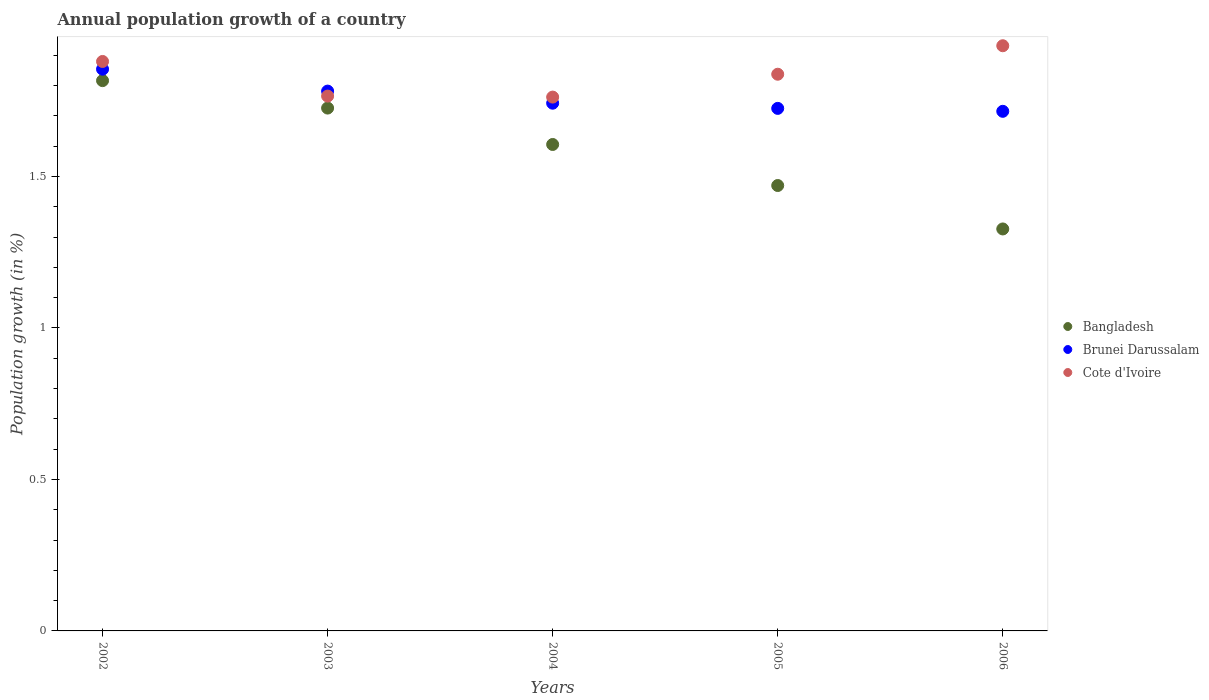What is the annual population growth in Cote d'Ivoire in 2002?
Give a very brief answer. 1.88. Across all years, what is the maximum annual population growth in Bangladesh?
Offer a very short reply. 1.82. Across all years, what is the minimum annual population growth in Cote d'Ivoire?
Ensure brevity in your answer.  1.76. In which year was the annual population growth in Cote d'Ivoire minimum?
Make the answer very short. 2004. What is the total annual population growth in Bangladesh in the graph?
Make the answer very short. 7.95. What is the difference between the annual population growth in Brunei Darussalam in 2005 and that in 2006?
Your answer should be compact. 0.01. What is the difference between the annual population growth in Brunei Darussalam in 2006 and the annual population growth in Bangladesh in 2004?
Give a very brief answer. 0.11. What is the average annual population growth in Bangladesh per year?
Your answer should be compact. 1.59. In the year 2002, what is the difference between the annual population growth in Cote d'Ivoire and annual population growth in Bangladesh?
Ensure brevity in your answer.  0.06. In how many years, is the annual population growth in Bangladesh greater than 1.8 %?
Keep it short and to the point. 1. What is the ratio of the annual population growth in Brunei Darussalam in 2002 to that in 2004?
Your answer should be compact. 1.06. Is the difference between the annual population growth in Cote d'Ivoire in 2004 and 2006 greater than the difference between the annual population growth in Bangladesh in 2004 and 2006?
Provide a short and direct response. No. What is the difference between the highest and the second highest annual population growth in Bangladesh?
Give a very brief answer. 0.09. What is the difference between the highest and the lowest annual population growth in Cote d'Ivoire?
Ensure brevity in your answer.  0.17. In how many years, is the annual population growth in Cote d'Ivoire greater than the average annual population growth in Cote d'Ivoire taken over all years?
Your response must be concise. 3. Is the annual population growth in Brunei Darussalam strictly less than the annual population growth in Bangladesh over the years?
Offer a very short reply. No. How many dotlines are there?
Your response must be concise. 3. How many years are there in the graph?
Provide a short and direct response. 5. What is the difference between two consecutive major ticks on the Y-axis?
Give a very brief answer. 0.5. Does the graph contain any zero values?
Offer a terse response. No. What is the title of the graph?
Your response must be concise. Annual population growth of a country. Does "Turkey" appear as one of the legend labels in the graph?
Offer a terse response. No. What is the label or title of the X-axis?
Give a very brief answer. Years. What is the label or title of the Y-axis?
Offer a terse response. Population growth (in %). What is the Population growth (in %) in Bangladesh in 2002?
Offer a terse response. 1.82. What is the Population growth (in %) of Brunei Darussalam in 2002?
Offer a terse response. 1.85. What is the Population growth (in %) in Cote d'Ivoire in 2002?
Give a very brief answer. 1.88. What is the Population growth (in %) in Bangladesh in 2003?
Your response must be concise. 1.73. What is the Population growth (in %) of Brunei Darussalam in 2003?
Ensure brevity in your answer.  1.78. What is the Population growth (in %) of Cote d'Ivoire in 2003?
Offer a very short reply. 1.77. What is the Population growth (in %) in Bangladesh in 2004?
Your answer should be very brief. 1.61. What is the Population growth (in %) of Brunei Darussalam in 2004?
Your answer should be compact. 1.74. What is the Population growth (in %) in Cote d'Ivoire in 2004?
Provide a short and direct response. 1.76. What is the Population growth (in %) in Bangladesh in 2005?
Offer a terse response. 1.47. What is the Population growth (in %) in Brunei Darussalam in 2005?
Ensure brevity in your answer.  1.72. What is the Population growth (in %) in Cote d'Ivoire in 2005?
Ensure brevity in your answer.  1.84. What is the Population growth (in %) of Bangladesh in 2006?
Offer a very short reply. 1.33. What is the Population growth (in %) of Brunei Darussalam in 2006?
Keep it short and to the point. 1.72. What is the Population growth (in %) in Cote d'Ivoire in 2006?
Offer a terse response. 1.93. Across all years, what is the maximum Population growth (in %) of Bangladesh?
Provide a succinct answer. 1.82. Across all years, what is the maximum Population growth (in %) of Brunei Darussalam?
Ensure brevity in your answer.  1.85. Across all years, what is the maximum Population growth (in %) in Cote d'Ivoire?
Your answer should be very brief. 1.93. Across all years, what is the minimum Population growth (in %) of Bangladesh?
Offer a terse response. 1.33. Across all years, what is the minimum Population growth (in %) in Brunei Darussalam?
Ensure brevity in your answer.  1.72. Across all years, what is the minimum Population growth (in %) in Cote d'Ivoire?
Make the answer very short. 1.76. What is the total Population growth (in %) of Bangladesh in the graph?
Give a very brief answer. 7.95. What is the total Population growth (in %) in Brunei Darussalam in the graph?
Keep it short and to the point. 8.82. What is the total Population growth (in %) of Cote d'Ivoire in the graph?
Provide a succinct answer. 9.18. What is the difference between the Population growth (in %) in Bangladesh in 2002 and that in 2003?
Offer a terse response. 0.09. What is the difference between the Population growth (in %) of Brunei Darussalam in 2002 and that in 2003?
Offer a terse response. 0.07. What is the difference between the Population growth (in %) in Cote d'Ivoire in 2002 and that in 2003?
Provide a succinct answer. 0.11. What is the difference between the Population growth (in %) of Bangladesh in 2002 and that in 2004?
Your response must be concise. 0.21. What is the difference between the Population growth (in %) in Brunei Darussalam in 2002 and that in 2004?
Provide a short and direct response. 0.11. What is the difference between the Population growth (in %) of Cote d'Ivoire in 2002 and that in 2004?
Offer a very short reply. 0.12. What is the difference between the Population growth (in %) of Bangladesh in 2002 and that in 2005?
Ensure brevity in your answer.  0.35. What is the difference between the Population growth (in %) of Brunei Darussalam in 2002 and that in 2005?
Your response must be concise. 0.13. What is the difference between the Population growth (in %) of Cote d'Ivoire in 2002 and that in 2005?
Offer a terse response. 0.04. What is the difference between the Population growth (in %) of Bangladesh in 2002 and that in 2006?
Offer a terse response. 0.49. What is the difference between the Population growth (in %) of Brunei Darussalam in 2002 and that in 2006?
Your answer should be compact. 0.14. What is the difference between the Population growth (in %) of Cote d'Ivoire in 2002 and that in 2006?
Your answer should be very brief. -0.05. What is the difference between the Population growth (in %) in Bangladesh in 2003 and that in 2004?
Offer a very short reply. 0.12. What is the difference between the Population growth (in %) in Brunei Darussalam in 2003 and that in 2004?
Offer a terse response. 0.04. What is the difference between the Population growth (in %) of Cote d'Ivoire in 2003 and that in 2004?
Provide a succinct answer. 0. What is the difference between the Population growth (in %) of Bangladesh in 2003 and that in 2005?
Your answer should be very brief. 0.26. What is the difference between the Population growth (in %) in Brunei Darussalam in 2003 and that in 2005?
Your answer should be compact. 0.06. What is the difference between the Population growth (in %) of Cote d'Ivoire in 2003 and that in 2005?
Your answer should be very brief. -0.07. What is the difference between the Population growth (in %) in Bangladesh in 2003 and that in 2006?
Keep it short and to the point. 0.4. What is the difference between the Population growth (in %) of Brunei Darussalam in 2003 and that in 2006?
Offer a very short reply. 0.07. What is the difference between the Population growth (in %) of Cote d'Ivoire in 2003 and that in 2006?
Your answer should be compact. -0.17. What is the difference between the Population growth (in %) in Bangladesh in 2004 and that in 2005?
Provide a succinct answer. 0.14. What is the difference between the Population growth (in %) in Brunei Darussalam in 2004 and that in 2005?
Offer a very short reply. 0.02. What is the difference between the Population growth (in %) of Cote d'Ivoire in 2004 and that in 2005?
Your response must be concise. -0.08. What is the difference between the Population growth (in %) of Bangladesh in 2004 and that in 2006?
Provide a succinct answer. 0.28. What is the difference between the Population growth (in %) of Brunei Darussalam in 2004 and that in 2006?
Your response must be concise. 0.03. What is the difference between the Population growth (in %) in Cote d'Ivoire in 2004 and that in 2006?
Make the answer very short. -0.17. What is the difference between the Population growth (in %) in Bangladesh in 2005 and that in 2006?
Offer a very short reply. 0.14. What is the difference between the Population growth (in %) of Brunei Darussalam in 2005 and that in 2006?
Your response must be concise. 0.01. What is the difference between the Population growth (in %) in Cote d'Ivoire in 2005 and that in 2006?
Make the answer very short. -0.09. What is the difference between the Population growth (in %) of Bangladesh in 2002 and the Population growth (in %) of Brunei Darussalam in 2003?
Keep it short and to the point. 0.03. What is the difference between the Population growth (in %) in Bangladesh in 2002 and the Population growth (in %) in Cote d'Ivoire in 2003?
Make the answer very short. 0.05. What is the difference between the Population growth (in %) in Brunei Darussalam in 2002 and the Population growth (in %) in Cote d'Ivoire in 2003?
Your answer should be very brief. 0.09. What is the difference between the Population growth (in %) of Bangladesh in 2002 and the Population growth (in %) of Brunei Darussalam in 2004?
Make the answer very short. 0.07. What is the difference between the Population growth (in %) in Bangladesh in 2002 and the Population growth (in %) in Cote d'Ivoire in 2004?
Offer a very short reply. 0.05. What is the difference between the Population growth (in %) in Brunei Darussalam in 2002 and the Population growth (in %) in Cote d'Ivoire in 2004?
Ensure brevity in your answer.  0.09. What is the difference between the Population growth (in %) in Bangladesh in 2002 and the Population growth (in %) in Brunei Darussalam in 2005?
Offer a very short reply. 0.09. What is the difference between the Population growth (in %) of Bangladesh in 2002 and the Population growth (in %) of Cote d'Ivoire in 2005?
Give a very brief answer. -0.02. What is the difference between the Population growth (in %) of Brunei Darussalam in 2002 and the Population growth (in %) of Cote d'Ivoire in 2005?
Provide a succinct answer. 0.02. What is the difference between the Population growth (in %) of Bangladesh in 2002 and the Population growth (in %) of Brunei Darussalam in 2006?
Your answer should be very brief. 0.1. What is the difference between the Population growth (in %) of Bangladesh in 2002 and the Population growth (in %) of Cote d'Ivoire in 2006?
Your answer should be compact. -0.12. What is the difference between the Population growth (in %) of Brunei Darussalam in 2002 and the Population growth (in %) of Cote d'Ivoire in 2006?
Keep it short and to the point. -0.08. What is the difference between the Population growth (in %) in Bangladesh in 2003 and the Population growth (in %) in Brunei Darussalam in 2004?
Make the answer very short. -0.02. What is the difference between the Population growth (in %) in Bangladesh in 2003 and the Population growth (in %) in Cote d'Ivoire in 2004?
Provide a short and direct response. -0.04. What is the difference between the Population growth (in %) of Brunei Darussalam in 2003 and the Population growth (in %) of Cote d'Ivoire in 2004?
Provide a succinct answer. 0.02. What is the difference between the Population growth (in %) of Bangladesh in 2003 and the Population growth (in %) of Brunei Darussalam in 2005?
Give a very brief answer. 0. What is the difference between the Population growth (in %) in Bangladesh in 2003 and the Population growth (in %) in Cote d'Ivoire in 2005?
Provide a short and direct response. -0.11. What is the difference between the Population growth (in %) in Brunei Darussalam in 2003 and the Population growth (in %) in Cote d'Ivoire in 2005?
Your response must be concise. -0.06. What is the difference between the Population growth (in %) of Bangladesh in 2003 and the Population growth (in %) of Brunei Darussalam in 2006?
Make the answer very short. 0.01. What is the difference between the Population growth (in %) of Bangladesh in 2003 and the Population growth (in %) of Cote d'Ivoire in 2006?
Provide a succinct answer. -0.21. What is the difference between the Population growth (in %) in Brunei Darussalam in 2003 and the Population growth (in %) in Cote d'Ivoire in 2006?
Provide a short and direct response. -0.15. What is the difference between the Population growth (in %) in Bangladesh in 2004 and the Population growth (in %) in Brunei Darussalam in 2005?
Your response must be concise. -0.12. What is the difference between the Population growth (in %) in Bangladesh in 2004 and the Population growth (in %) in Cote d'Ivoire in 2005?
Make the answer very short. -0.23. What is the difference between the Population growth (in %) in Brunei Darussalam in 2004 and the Population growth (in %) in Cote d'Ivoire in 2005?
Your answer should be compact. -0.1. What is the difference between the Population growth (in %) in Bangladesh in 2004 and the Population growth (in %) in Brunei Darussalam in 2006?
Give a very brief answer. -0.11. What is the difference between the Population growth (in %) in Bangladesh in 2004 and the Population growth (in %) in Cote d'Ivoire in 2006?
Give a very brief answer. -0.33. What is the difference between the Population growth (in %) of Brunei Darussalam in 2004 and the Population growth (in %) of Cote d'Ivoire in 2006?
Give a very brief answer. -0.19. What is the difference between the Population growth (in %) of Bangladesh in 2005 and the Population growth (in %) of Brunei Darussalam in 2006?
Your response must be concise. -0.24. What is the difference between the Population growth (in %) in Bangladesh in 2005 and the Population growth (in %) in Cote d'Ivoire in 2006?
Your answer should be very brief. -0.46. What is the difference between the Population growth (in %) of Brunei Darussalam in 2005 and the Population growth (in %) of Cote d'Ivoire in 2006?
Provide a short and direct response. -0.21. What is the average Population growth (in %) of Bangladesh per year?
Offer a very short reply. 1.59. What is the average Population growth (in %) in Brunei Darussalam per year?
Your answer should be very brief. 1.76. What is the average Population growth (in %) of Cote d'Ivoire per year?
Provide a short and direct response. 1.84. In the year 2002, what is the difference between the Population growth (in %) of Bangladesh and Population growth (in %) of Brunei Darussalam?
Make the answer very short. -0.04. In the year 2002, what is the difference between the Population growth (in %) in Bangladesh and Population growth (in %) in Cote d'Ivoire?
Offer a very short reply. -0.06. In the year 2002, what is the difference between the Population growth (in %) of Brunei Darussalam and Population growth (in %) of Cote d'Ivoire?
Offer a terse response. -0.03. In the year 2003, what is the difference between the Population growth (in %) of Bangladesh and Population growth (in %) of Brunei Darussalam?
Your answer should be compact. -0.06. In the year 2003, what is the difference between the Population growth (in %) in Bangladesh and Population growth (in %) in Cote d'Ivoire?
Offer a very short reply. -0.04. In the year 2003, what is the difference between the Population growth (in %) in Brunei Darussalam and Population growth (in %) in Cote d'Ivoire?
Provide a succinct answer. 0.02. In the year 2004, what is the difference between the Population growth (in %) in Bangladesh and Population growth (in %) in Brunei Darussalam?
Your response must be concise. -0.14. In the year 2004, what is the difference between the Population growth (in %) of Bangladesh and Population growth (in %) of Cote d'Ivoire?
Your answer should be compact. -0.16. In the year 2004, what is the difference between the Population growth (in %) in Brunei Darussalam and Population growth (in %) in Cote d'Ivoire?
Provide a short and direct response. -0.02. In the year 2005, what is the difference between the Population growth (in %) of Bangladesh and Population growth (in %) of Brunei Darussalam?
Provide a short and direct response. -0.25. In the year 2005, what is the difference between the Population growth (in %) in Bangladesh and Population growth (in %) in Cote d'Ivoire?
Offer a very short reply. -0.37. In the year 2005, what is the difference between the Population growth (in %) of Brunei Darussalam and Population growth (in %) of Cote d'Ivoire?
Your answer should be compact. -0.11. In the year 2006, what is the difference between the Population growth (in %) of Bangladesh and Population growth (in %) of Brunei Darussalam?
Your response must be concise. -0.39. In the year 2006, what is the difference between the Population growth (in %) in Bangladesh and Population growth (in %) in Cote d'Ivoire?
Offer a very short reply. -0.6. In the year 2006, what is the difference between the Population growth (in %) of Brunei Darussalam and Population growth (in %) of Cote d'Ivoire?
Provide a short and direct response. -0.22. What is the ratio of the Population growth (in %) of Bangladesh in 2002 to that in 2003?
Keep it short and to the point. 1.05. What is the ratio of the Population growth (in %) in Brunei Darussalam in 2002 to that in 2003?
Make the answer very short. 1.04. What is the ratio of the Population growth (in %) in Cote d'Ivoire in 2002 to that in 2003?
Your response must be concise. 1.06. What is the ratio of the Population growth (in %) of Bangladesh in 2002 to that in 2004?
Make the answer very short. 1.13. What is the ratio of the Population growth (in %) of Brunei Darussalam in 2002 to that in 2004?
Provide a short and direct response. 1.06. What is the ratio of the Population growth (in %) in Cote d'Ivoire in 2002 to that in 2004?
Your answer should be very brief. 1.07. What is the ratio of the Population growth (in %) in Bangladesh in 2002 to that in 2005?
Ensure brevity in your answer.  1.24. What is the ratio of the Population growth (in %) in Brunei Darussalam in 2002 to that in 2005?
Offer a very short reply. 1.07. What is the ratio of the Population growth (in %) of Cote d'Ivoire in 2002 to that in 2005?
Your response must be concise. 1.02. What is the ratio of the Population growth (in %) in Bangladesh in 2002 to that in 2006?
Make the answer very short. 1.37. What is the ratio of the Population growth (in %) of Brunei Darussalam in 2002 to that in 2006?
Your answer should be very brief. 1.08. What is the ratio of the Population growth (in %) in Cote d'Ivoire in 2002 to that in 2006?
Make the answer very short. 0.97. What is the ratio of the Population growth (in %) of Bangladesh in 2003 to that in 2004?
Offer a very short reply. 1.07. What is the ratio of the Population growth (in %) of Brunei Darussalam in 2003 to that in 2004?
Give a very brief answer. 1.02. What is the ratio of the Population growth (in %) in Bangladesh in 2003 to that in 2005?
Your answer should be very brief. 1.17. What is the ratio of the Population growth (in %) in Brunei Darussalam in 2003 to that in 2005?
Your answer should be compact. 1.03. What is the ratio of the Population growth (in %) of Cote d'Ivoire in 2003 to that in 2005?
Offer a very short reply. 0.96. What is the ratio of the Population growth (in %) of Bangladesh in 2003 to that in 2006?
Provide a succinct answer. 1.3. What is the ratio of the Population growth (in %) of Brunei Darussalam in 2003 to that in 2006?
Provide a short and direct response. 1.04. What is the ratio of the Population growth (in %) of Cote d'Ivoire in 2003 to that in 2006?
Make the answer very short. 0.91. What is the ratio of the Population growth (in %) of Bangladesh in 2004 to that in 2005?
Provide a short and direct response. 1.09. What is the ratio of the Population growth (in %) of Brunei Darussalam in 2004 to that in 2005?
Provide a short and direct response. 1.01. What is the ratio of the Population growth (in %) in Cote d'Ivoire in 2004 to that in 2005?
Your response must be concise. 0.96. What is the ratio of the Population growth (in %) in Bangladesh in 2004 to that in 2006?
Your answer should be very brief. 1.21. What is the ratio of the Population growth (in %) in Brunei Darussalam in 2004 to that in 2006?
Offer a very short reply. 1.02. What is the ratio of the Population growth (in %) in Cote d'Ivoire in 2004 to that in 2006?
Your answer should be very brief. 0.91. What is the ratio of the Population growth (in %) in Bangladesh in 2005 to that in 2006?
Offer a very short reply. 1.11. What is the ratio of the Population growth (in %) of Cote d'Ivoire in 2005 to that in 2006?
Offer a terse response. 0.95. What is the difference between the highest and the second highest Population growth (in %) of Bangladesh?
Provide a short and direct response. 0.09. What is the difference between the highest and the second highest Population growth (in %) of Brunei Darussalam?
Make the answer very short. 0.07. What is the difference between the highest and the second highest Population growth (in %) in Cote d'Ivoire?
Your answer should be compact. 0.05. What is the difference between the highest and the lowest Population growth (in %) of Bangladesh?
Your answer should be very brief. 0.49. What is the difference between the highest and the lowest Population growth (in %) of Brunei Darussalam?
Provide a succinct answer. 0.14. What is the difference between the highest and the lowest Population growth (in %) of Cote d'Ivoire?
Give a very brief answer. 0.17. 